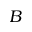Convert formula to latex. <formula><loc_0><loc_0><loc_500><loc_500>B</formula> 